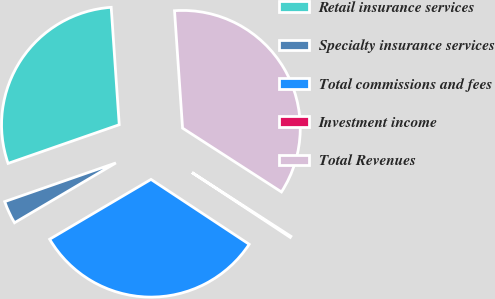Convert chart to OTSL. <chart><loc_0><loc_0><loc_500><loc_500><pie_chart><fcel>Retail insurance services<fcel>Specialty insurance services<fcel>Total commissions and fees<fcel>Investment income<fcel>Total Revenues<nl><fcel>29.24%<fcel>3.16%<fcel>32.22%<fcel>0.17%<fcel>35.21%<nl></chart> 